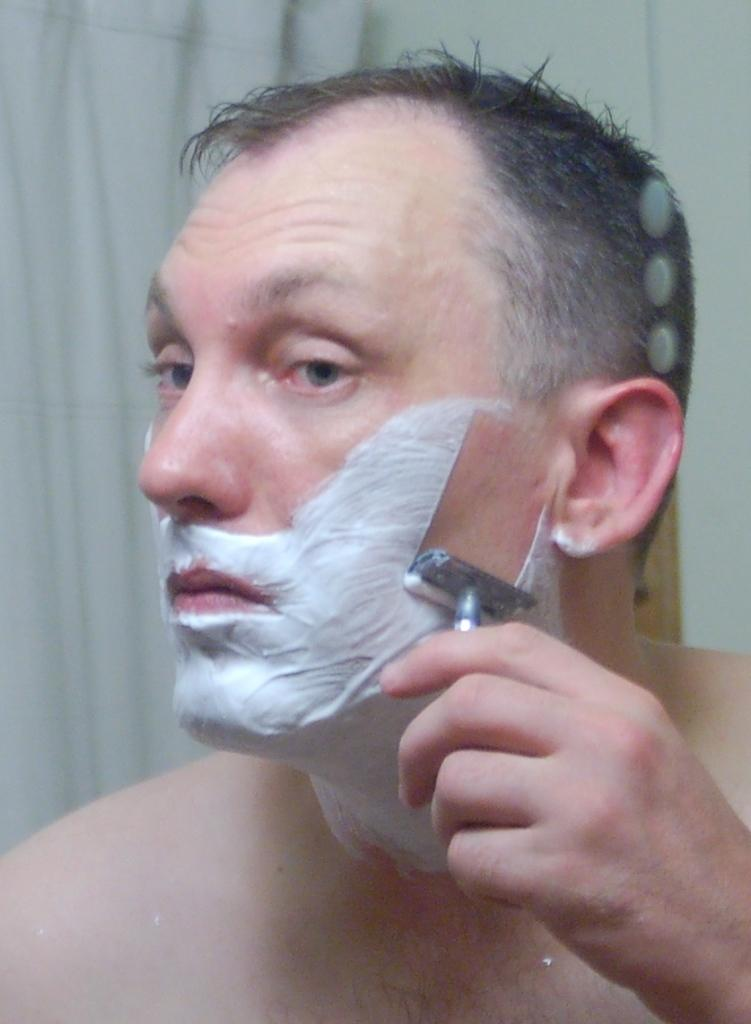What is the main subject of the image? The main subject of the image is a man. What is the man doing in the image? The man is doing shaving in the image. What is the man's temper like during the shaving process in the image? The image does not provide any information about the man's temper during the shaving process. 